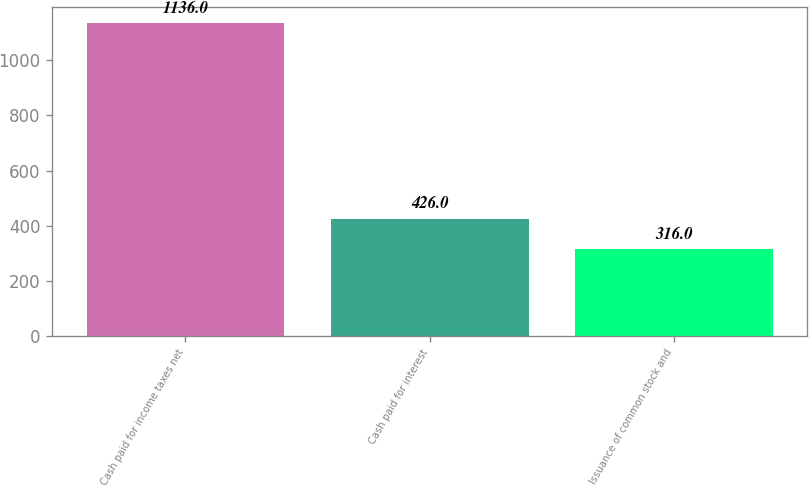Convert chart. <chart><loc_0><loc_0><loc_500><loc_500><bar_chart><fcel>Cash paid for income taxes net<fcel>Cash paid for interest<fcel>Issuance of common stock and<nl><fcel>1136<fcel>426<fcel>316<nl></chart> 